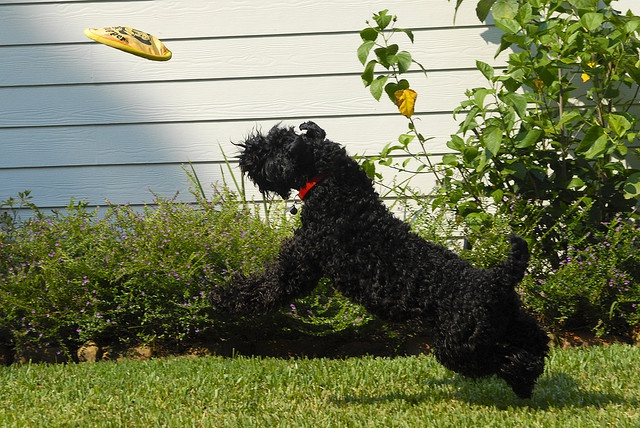Describe the objects in this image and their specific colors. I can see dog in darkgray, black, gray, and darkgreen tones, potted plant in darkgray, black, darkgreen, and gray tones, and frisbee in darkgray, khaki, gold, tan, and olive tones in this image. 